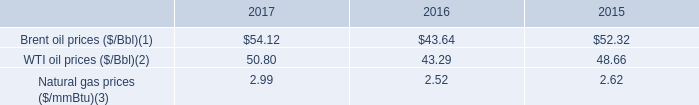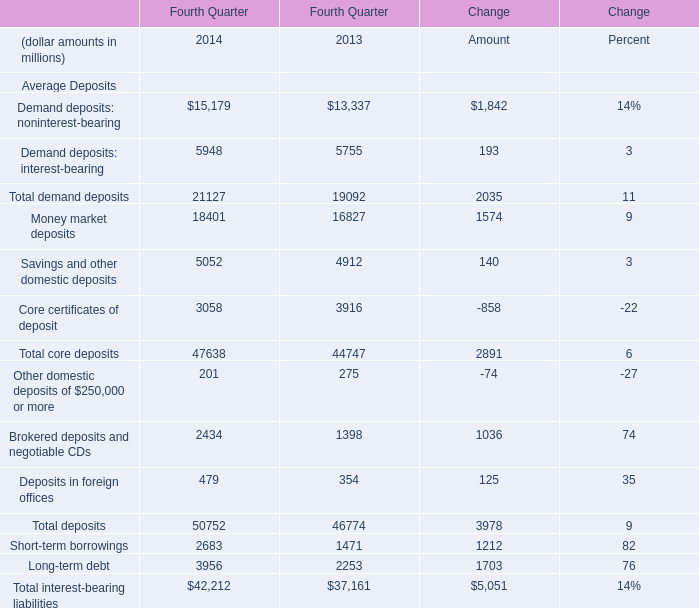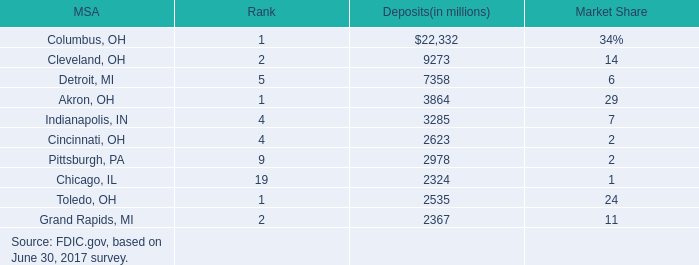What is the sum of the Core certificates of deposit in the years where Total deposits greater than 0 ? (in million) 
Computations: (((3058 + 3916) - 858) - 22)
Answer: 6094.0. 